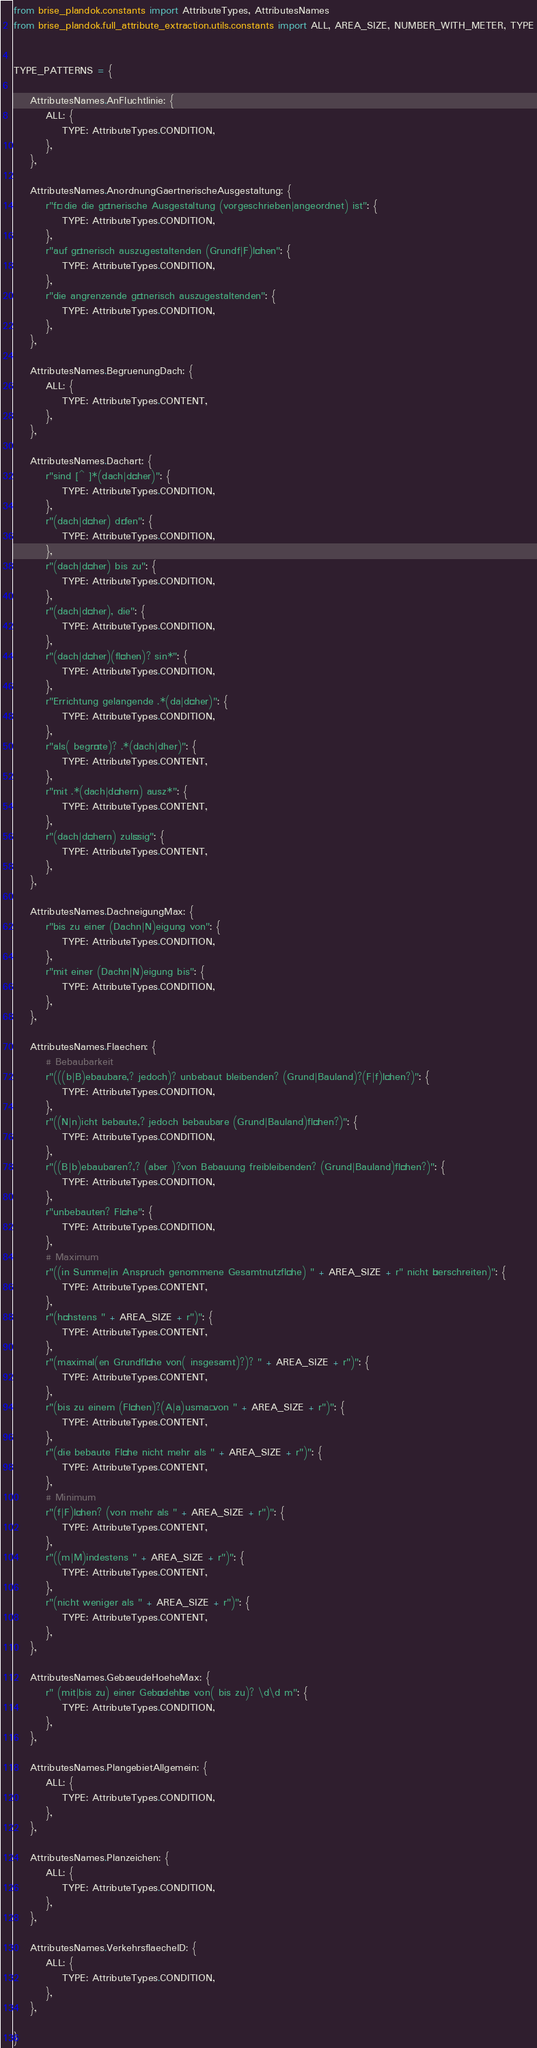Convert code to text. <code><loc_0><loc_0><loc_500><loc_500><_Python_>

from brise_plandok.constants import AttributeTypes, AttributesNames
from brise_plandok.full_attribute_extraction.utils.constants import ALL, AREA_SIZE, NUMBER_WITH_METER, TYPE


TYPE_PATTERNS = {

    AttributesNames.AnFluchtlinie: {
        ALL: {
            TYPE: AttributeTypes.CONDITION,
        },
    },

    AttributesNames.AnordnungGaertnerischeAusgestaltung: {
        r"für die die gärtnerische Ausgestaltung (vorgeschrieben|angeordnet) ist": {
            TYPE: AttributeTypes.CONDITION,
        },
        r"auf gärtnerisch auszugestaltenden (Grundf|F)lächen": {
            TYPE: AttributeTypes.CONDITION,
        },
        r"die angrenzende gärtnerisch auszugestaltenden": {
            TYPE: AttributeTypes.CONDITION,
        },
    },

    AttributesNames.BegruenungDach: {
        ALL: {
            TYPE: AttributeTypes.CONTENT,
        },
    },

    AttributesNames.Dachart: {
        r"sind [^ ]*(dach|dächer)": {
            TYPE: AttributeTypes.CONDITION,
        },
        r"(dach|dächer) dürfen": {
            TYPE: AttributeTypes.CONDITION,
        },
        r"(dach|dächer) bis zu": {
            TYPE: AttributeTypes.CONDITION,
        },
        r"(dach|dächer), die": {
            TYPE: AttributeTypes.CONDITION,
        },
        r"(dach|dächer)(flächen)? sin*": {
            TYPE: AttributeTypes.CONDITION,
        },
        r"Errichtung gelangende .*(da|dächer)": {
            TYPE: AttributeTypes.CONDITION,
        },
        r"als( begrünte)? .*(dach|dher)": {
            TYPE: AttributeTypes.CONTENT,
        },
        r"mit .*(dach|dächern) ausz*": {
            TYPE: AttributeTypes.CONTENT,
        },
        r"(dach|dächern) zulässig": {
            TYPE: AttributeTypes.CONTENT,
        },
    },

    AttributesNames.DachneigungMax: {
        r"bis zu einer (Dachn|N)eigung von": {
            TYPE: AttributeTypes.CONDITION,
        },
        r"mit einer (Dachn|N)eigung bis": {
            TYPE: AttributeTypes.CONDITION,
        },
    },

    AttributesNames.Flaechen: {
        # Bebaubarkeit
        r"(((b|B)ebaubare,? jedoch)? unbebaut bleibenden? (Grund|Bauland)?(F|f)lächen?)": {
            TYPE: AttributeTypes.CONDITION,
        },
        r"((N|n)icht bebaute,? jedoch bebaubare (Grund|Bauland)flächen?)": {
            TYPE: AttributeTypes.CONDITION,
        },
        r"((B|b)ebaubaren?,? (aber )?von Bebauung freibleibenden? (Grund|Bauland)flächen?)": {
            TYPE: AttributeTypes.CONDITION,
        },
        r"unbebauten? Fläche": {
            TYPE: AttributeTypes.CONDITION,
        },
        # Maximum
        r"((in Summe|in Anspruch genommene Gesamtnutzfläche) " + AREA_SIZE + r" nicht überschreiten)": {
            TYPE: AttributeTypes.CONTENT,
        },
        r"(höchstens " + AREA_SIZE + r")": {
            TYPE: AttributeTypes.CONTENT,
        },
        r"(maximal(en Grundfläche von( insgesamt)?)? " + AREA_SIZE + r")": {
            TYPE: AttributeTypes.CONTENT,
        },
        r"(bis zu einem (Flächen)?(A|a)usmaß von " + AREA_SIZE + r")": {
            TYPE: AttributeTypes.CONTENT,
        },
        r"(die bebaute Fläche nicht mehr als " + AREA_SIZE + r")": {
            TYPE: AttributeTypes.CONTENT,
        },
        # Minimum
        r"(f|F)lächen? (von mehr als " + AREA_SIZE + r")": {
            TYPE: AttributeTypes.CONTENT,
        },
        r"((m|M)indestens " + AREA_SIZE + r")": {
            TYPE: AttributeTypes.CONTENT,
        },
        r"(nicht weniger als " + AREA_SIZE + r")": {
            TYPE: AttributeTypes.CONTENT,
        },
    },

    AttributesNames.GebaeudeHoeheMax: {
        r" (mit|bis zu) einer Gebäudehöhe von( bis zu)? \d\d m": {
            TYPE: AttributeTypes.CONDITION,
        },
    },

    AttributesNames.PlangebietAllgemein: {
        ALL: {
            TYPE: AttributeTypes.CONDITION,
        },
    },

    AttributesNames.Planzeichen: {
        ALL: {
            TYPE: AttributeTypes.CONDITION,
        },
    },

    AttributesNames.VerkehrsflaecheID: {
        ALL: {
            TYPE: AttributeTypes.CONDITION,
        },
    },

}
</code> 